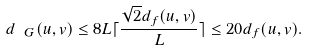Convert formula to latex. <formula><loc_0><loc_0><loc_500><loc_500>d _ { \ G } ( u , v ) \leq 8 L \lceil \frac { \sqrt { 2 } d _ { f } ( u , v ) } { L } \rceil \leq 2 0 d _ { f } ( u , v ) .</formula> 